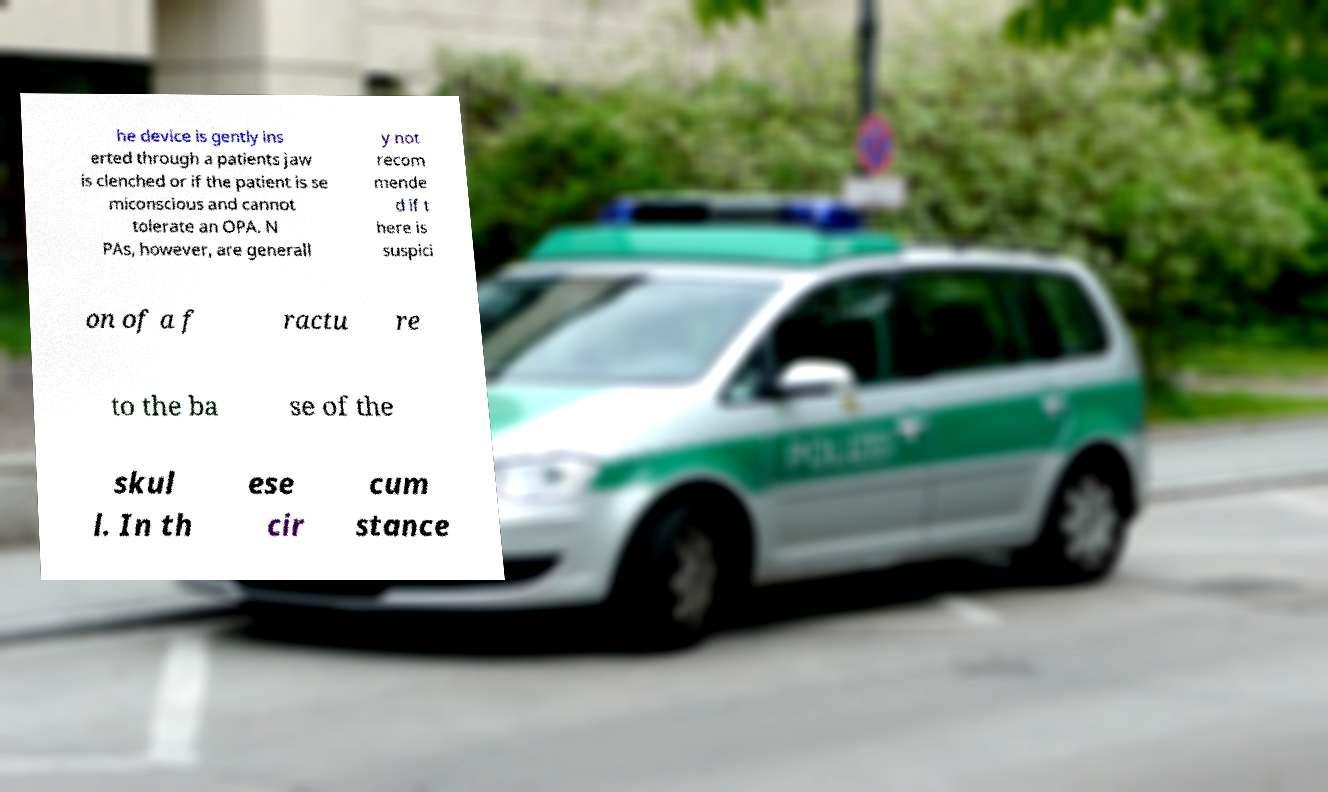Please identify and transcribe the text found in this image. he device is gently ins erted through a patients jaw is clenched or if the patient is se miconscious and cannot tolerate an OPA. N PAs, however, are generall y not recom mende d if t here is suspici on of a f ractu re to the ba se of the skul l. In th ese cir cum stance 